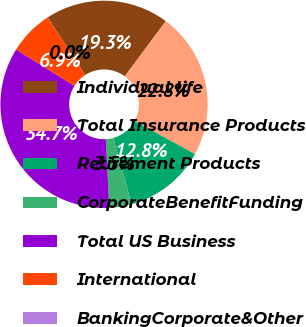<chart> <loc_0><loc_0><loc_500><loc_500><pie_chart><fcel>Individual life<fcel>Total Insurance Products<fcel>Retirement Products<fcel>CorporateBenefitFunding<fcel>Total US Business<fcel>International<fcel>BankingCorporate&Other<nl><fcel>19.34%<fcel>22.8%<fcel>12.75%<fcel>3.48%<fcel>34.68%<fcel>6.94%<fcel>0.01%<nl></chart> 